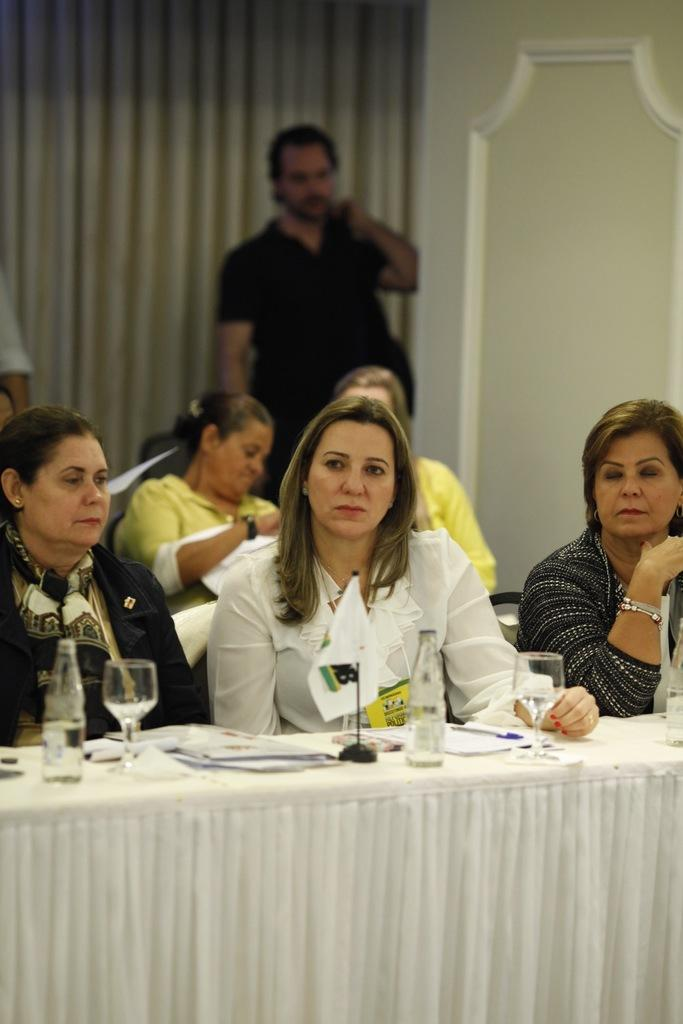How many people are in the image? There is a group of people in the image. What are the people doing in the image? The people are sitting on chairs. What objects can be seen on the table in the image? There is a glass, a bottle, a paper, and a pen on the table in the image. What is visible in the background of the image? There is a curtain and a man in the background of the image. What type of chalk is being used by the people in the image? There is no chalk present in the image; the people are sitting on chairs and there are objects on the table, but no chalk is mentioned. 